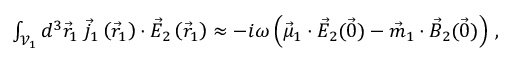<formula> <loc_0><loc_0><loc_500><loc_500>\begin{array} { r } { \int _ { \mathcal { V } _ { 1 } } d ^ { 3 } \vec { r } _ { 1 } \, \vec { j } _ { 1 } \left ( \vec { r } _ { 1 } \right ) \cdot \vec { E } _ { 2 } \left ( \vec { r } _ { 1 } \right ) \approx - i \omega \left ( \vec { \mu } _ { 1 } \cdot \vec { E } _ { 2 } ( \vec { 0 } ) - \vec { m } _ { 1 } \cdot \vec { B } _ { 2 } ( \vec { 0 } ) \right ) \, , } \end{array}</formula> 